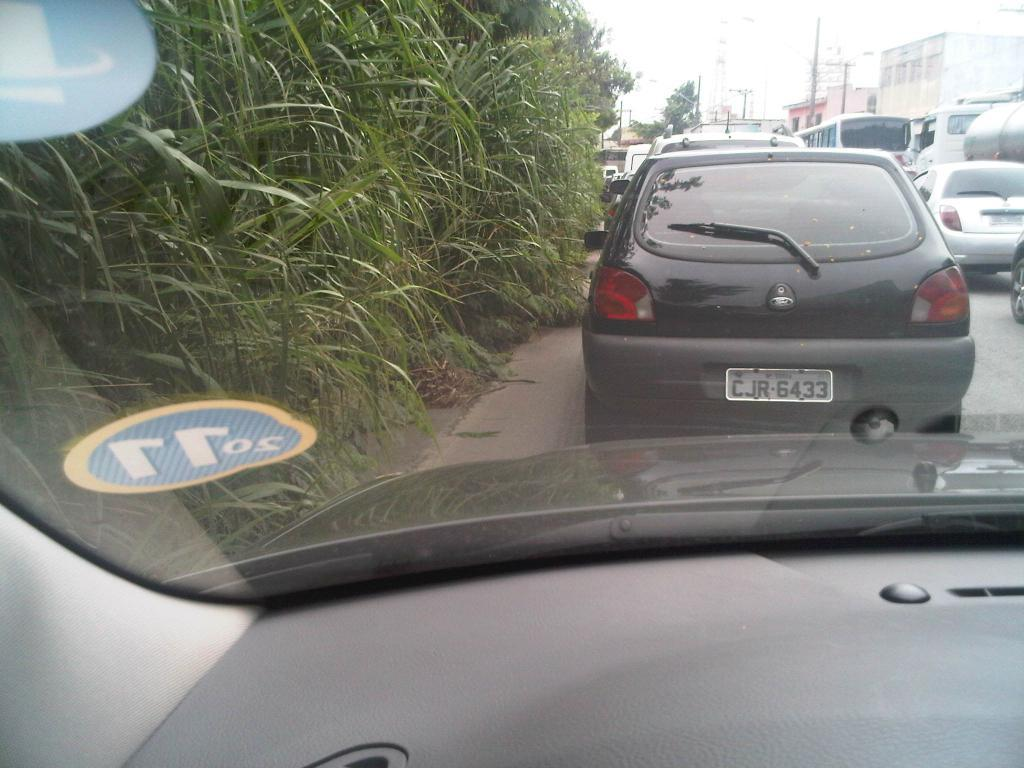<image>
Relay a brief, clear account of the picture shown. White license plate on a car which says CJR6433. 